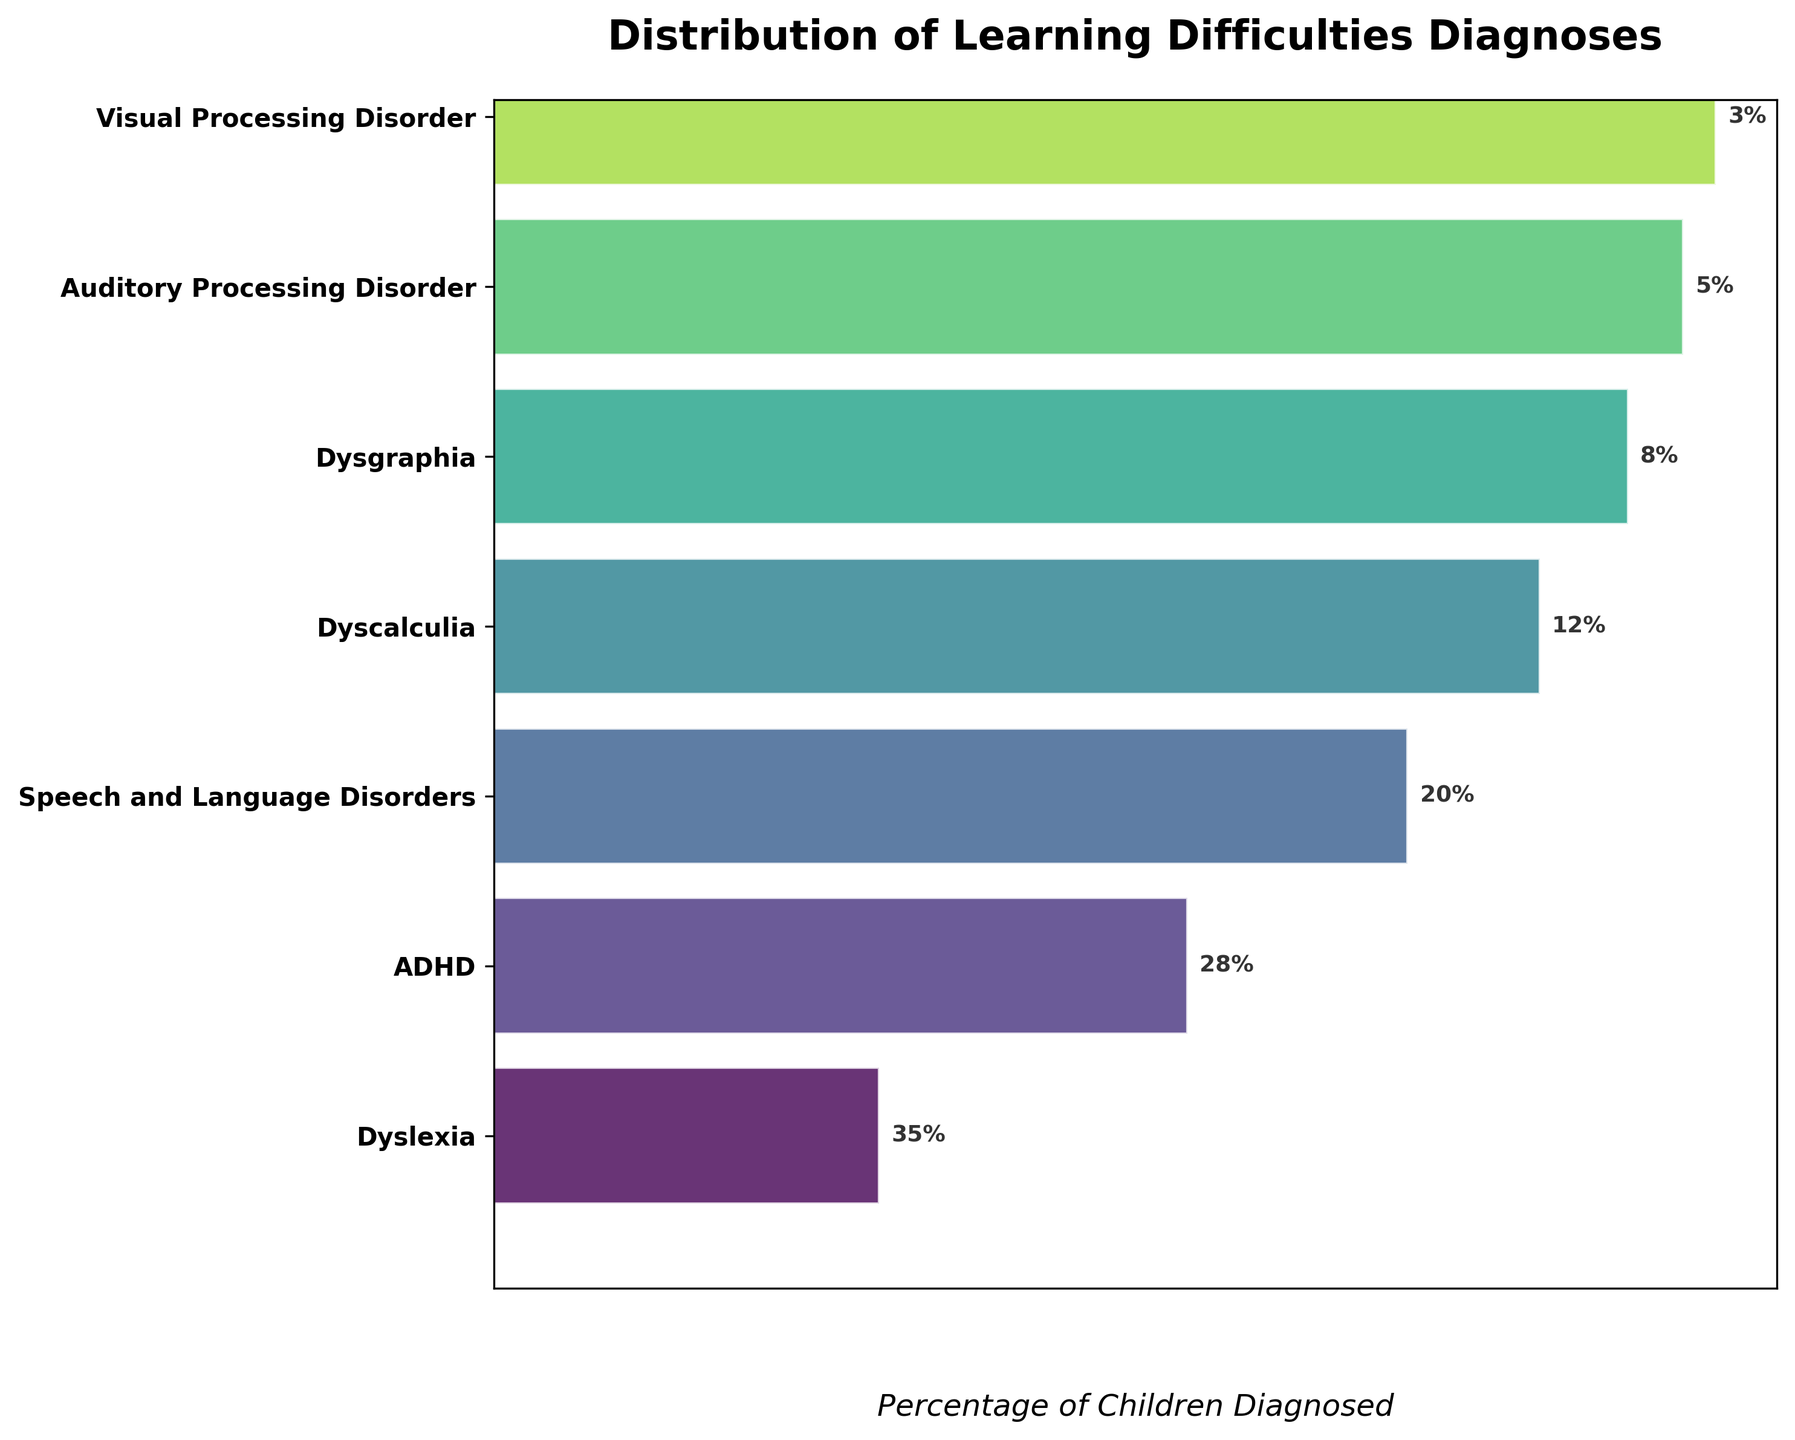What is the most commonly diagnosed learning difficulty? The most commonly diagnosed learning difficulty is represented by the widest section at the top of the funnel, which is Dyslexia
Answer: Dyslexia What is the percentage of children diagnosed with ADHD? The figure shows a percentage label next to ADHD, which is 28%
Answer: 28% How many learning difficulties are listed in the chart? By counting the labels on the y-axis of the funnel chart, there are seven learning difficulties listed
Answer: 7 What is the sum of percentages for Dyscalculia and Dysgraphia? According to the figure, Dyscalculia is 12% and Dysgraphia is 8%. Summing these gives 12% + 8% = 20%
Answer: 20% Which condition has a lower percentage, Auditory Processing Disorder or Visual Processing Disorder? Auditory Processing Disorder has 5%, and Visual Processing Disorder has 3%, so Visual Processing Disorder has a lower percentage
Answer: Visual Processing Disorder What is the total percentage of children diagnosed with Dyslexia, ADHD, and Speech and Language Disorders combined? The percentages are Dyslexia 35%, ADHD 28%, and Speech and Language Disorders 20%. Summing these gives 35% + 28% + 20% = 83%
Answer: 83% Compare the percentage of Dysgraphia to Dyscalculia. Which one is higher and by how much? Dyscalculia is 12% and Dysgraphia is 8%. Dyscalculia is higher by 4%. Subtracting these gives 12% - 8% = 4%
Answer: Dyscalculia, 4% What percentage of children have disorders less common than Dyscalculia? Disorders less common than Dyscalculia are Dysgraphia, Auditory Processing Disorder, and Visual Processing Disorder. Their percentages are 8%, 5%, and 3%, respectively. Summing these gives 8% + 5% + 3% = 16%
Answer: 16% What is the least commonly diagnosed learning difficulty? By looking at the bottom of the funnel, the least commonly diagnosed learning difficulty is Visual Processing Disorder
Answer: Visual Processing Disorder How many learning difficulties have a diagnosis percentage of 20% or more? By inspecting the figure, the conditions with 20% or more are Dyslexia, ADHD, and Speech and Language Disorders, making it three conditions
Answer: 3 